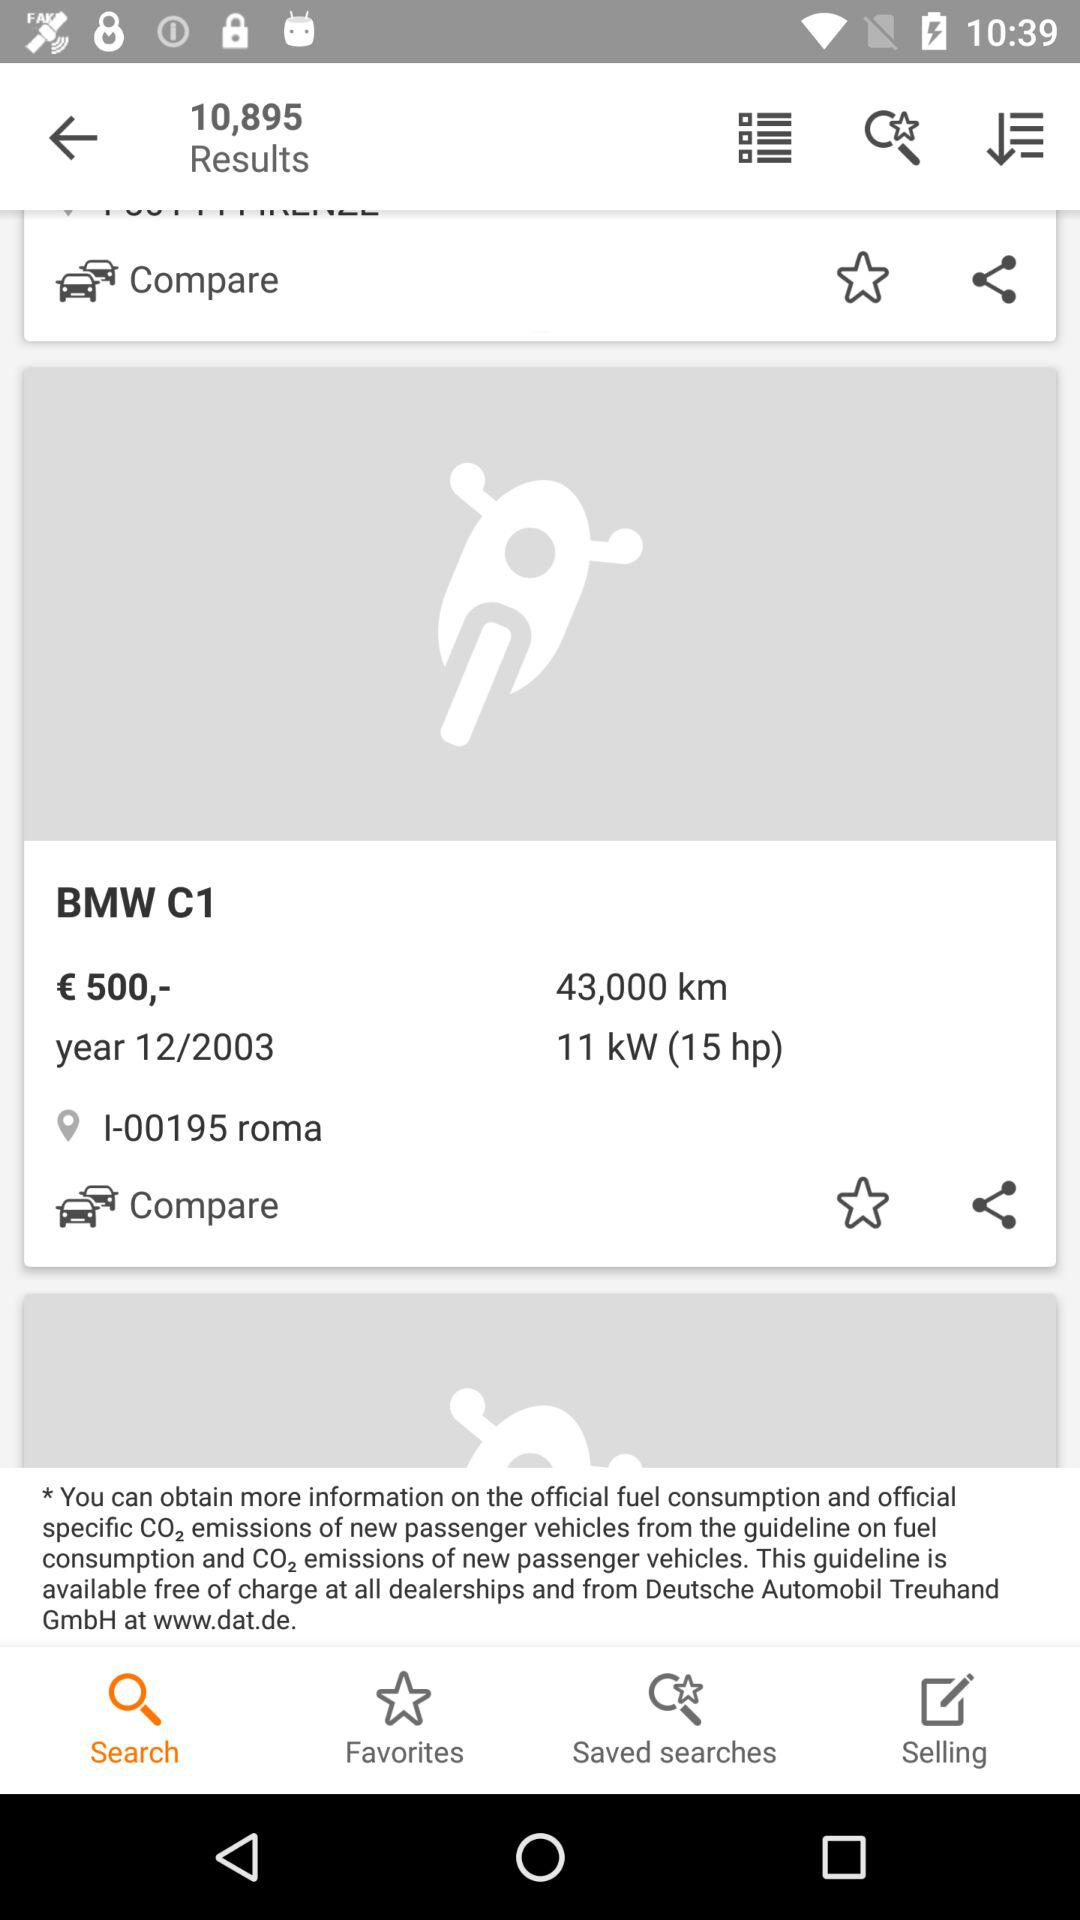What is the location? The location is I-00195 roma. 